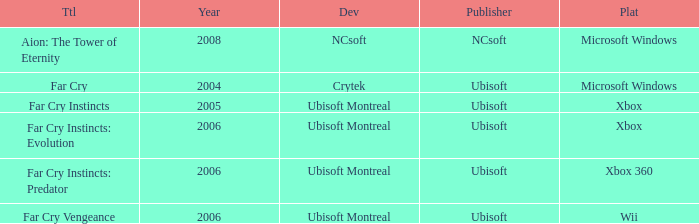What is the average year that has far cry vengeance as the title? 2006.0. 